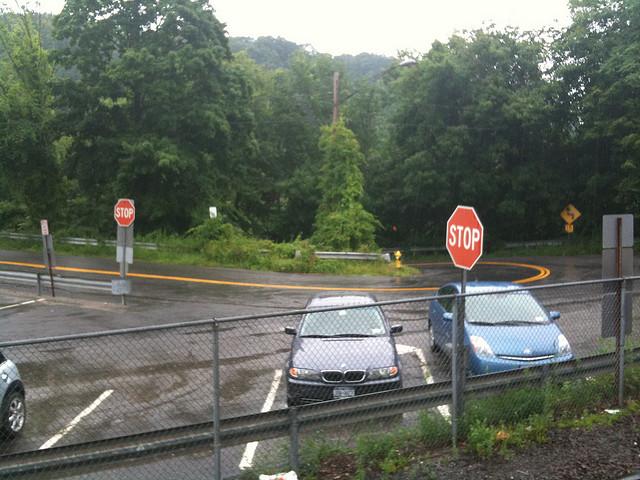Is this a freeway?
Short answer required. No. Does the weather appear rainy?
Quick response, please. Yes. Does this look like a heavy storm?
Keep it brief. No. 